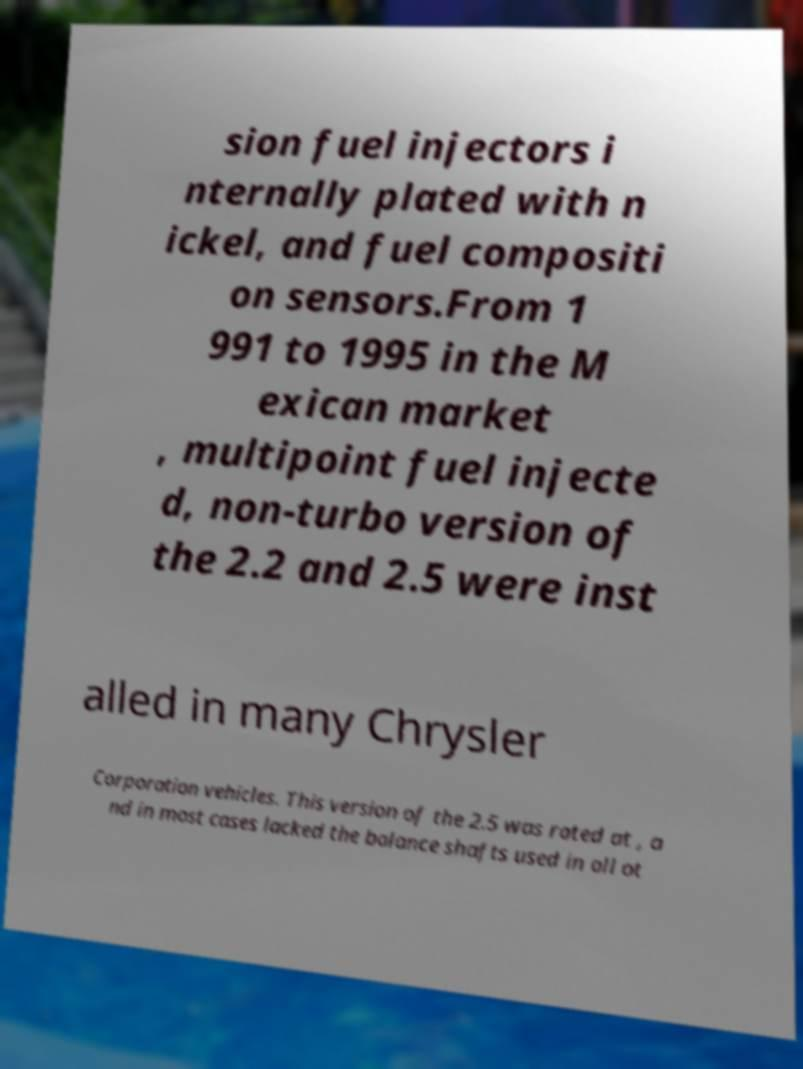Can you accurately transcribe the text from the provided image for me? sion fuel injectors i nternally plated with n ickel, and fuel compositi on sensors.From 1 991 to 1995 in the M exican market , multipoint fuel injecte d, non-turbo version of the 2.2 and 2.5 were inst alled in many Chrysler Corporation vehicles. This version of the 2.5 was rated at , a nd in most cases lacked the balance shafts used in all ot 